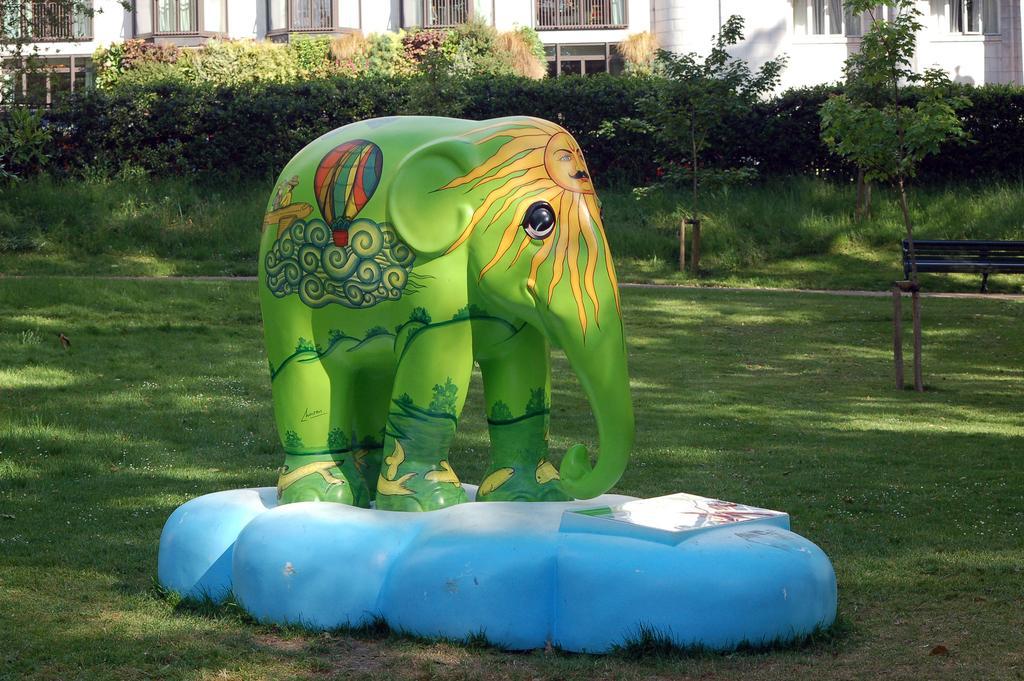In one or two sentences, can you explain what this image depicts? In the middle of the picture, we see the statue of the elephant standing on the blue color rock. This elephant is in green color. At the bottom of the picture, we see grass. Behind the elephant, we see trees and buildings in white color. On the right side, we see an iron bench. 